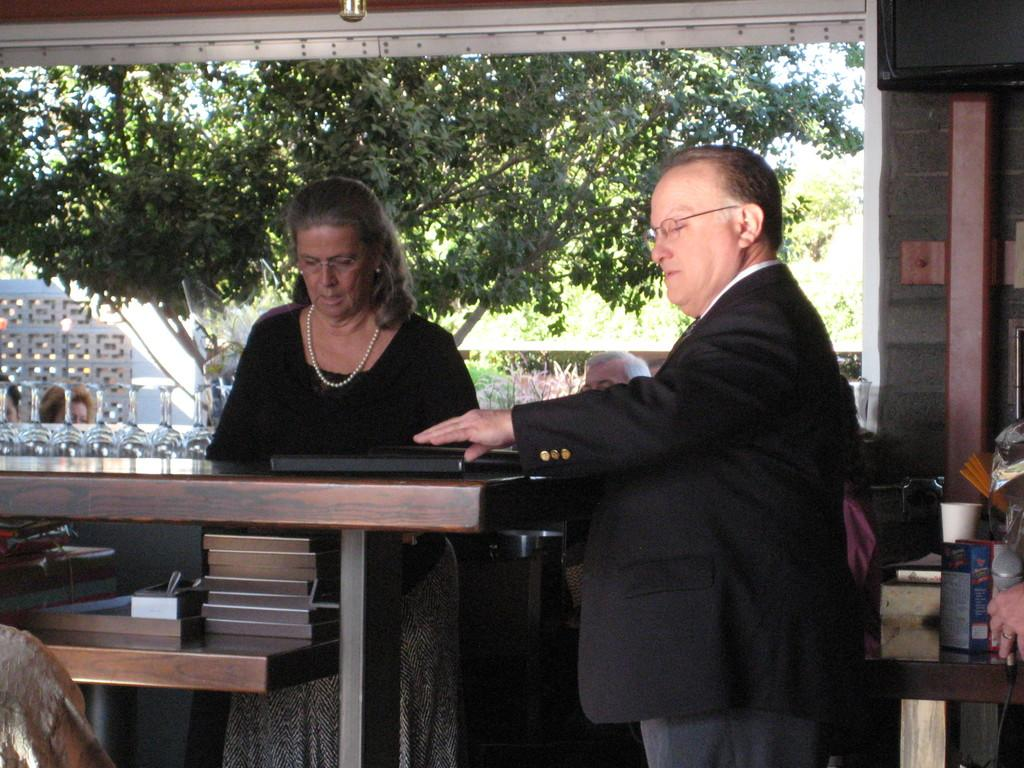What is the main subject of the image? There is a person standing at the center of the image. Can you describe the positioning of the other person in the image? There is a woman standing to the left of the person. What can be seen in the background of the image? There are trees visible in the background of the image. What type of cup is being used by the person on their journey in the image? There is no cup or journey present in the image. Can you tell me how many sea creatures are visible in the image? There are no sea creatures visible in the image. 